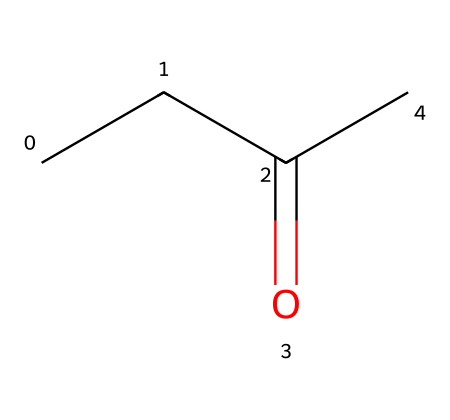What is the name of this chemical? The SMILES representation "CCC(=O)C" corresponds to the structure of 2-butanone, which is a common ketone.
Answer: 2-butanone How many carbon atoms are in 2-butanone? The structure "CCC(=O)C" indicates there are four carbon (C) atoms in total: three in the straight chain and one in the carbonyl group (C=O).
Answer: four What type of functional group is present in 2-butanone? The "(=O)" indicates that there is a carbonyl group (C=O) present, which is characteristic of ketones.
Answer: ketone What is the total number of hydrogen atoms in 2-butanone? In the structure, each carbon atom in a ketone can be connected to enough hydrogen atoms to make four total bonds; thus, there are six hydrogen atoms in 2-butanone.
Answer: six How many double bonds are present in 2-butanone? The only double bond in the structure is from the carbonyl group to oxygen, which counts as the one double bond in the molecule.
Answer: one Is 2-butanone a primary or secondary ketone? The carbonyl group is bonded to two other carbon atoms, indicating that 2-butanone is a secondary ketone.
Answer: secondary What is one common use of 2-butanone? It is commonly used as a solvent in cleaning products, which highlights its application in various industrial processes.
Answer: solvent 